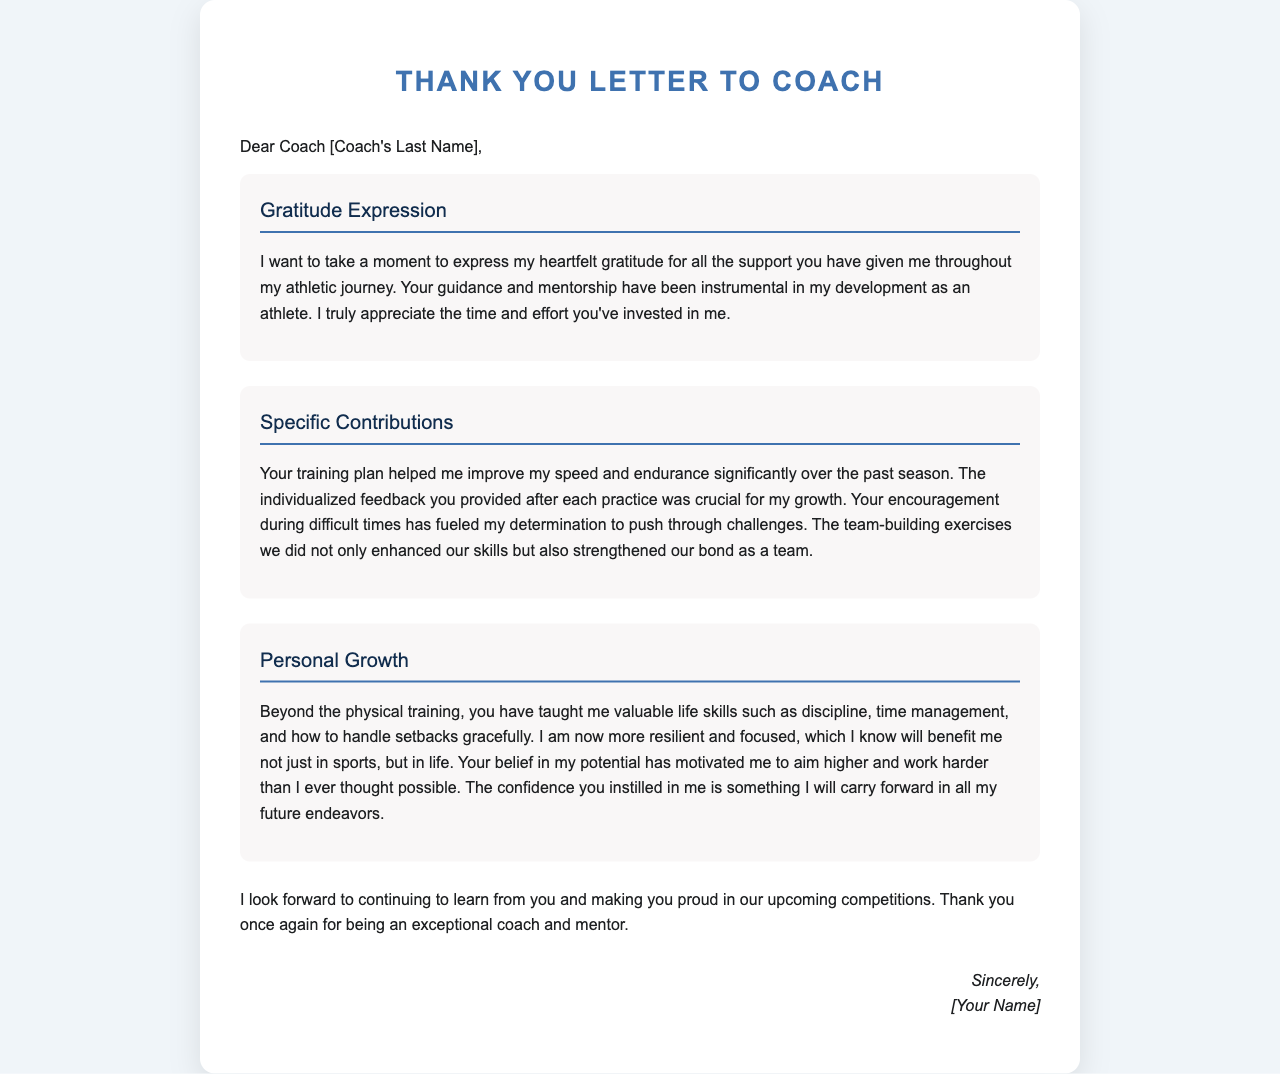What is the title of the letter? The title is clearly stated at the beginning of the document and is indicative of the letter's purpose.
Answer: Thank You Letter to Coach Who is the letter addressed to? The letter includes a placeholder for the recipient's name, specifically indicating the role they play in the author's life.
Answer: Coach [Coach's Last Name] What season did the author mention in their letter? The specific timeframe of the author’s athletic performance improvement is highlighted within the content of the letter.
Answer: Past season What skills did the coach help the author develop besides athletic skills? The letter explicitly mentions valuable life skills that the coach contributed to the author's growth.
Answer: Discipline, time management, handling setbacks What does the author look forward to doing in the future? The author expresses their eagerness regarding future events and ongoing learning from the coach in this closing statement.
Answer: Continuing to learn from you What expression of gratitude does the author make? The author shares a sentiment that reflects their feelings toward the coach's contributions in their athletic journey.
Answer: Heartfelt gratitude What type of letter is this? The specific format and content of the letter suggest its primary purpose within the context.
Answer: Thank-you letter What has the coach instilled in the author aside from skills? The author identifies a profound impact that transcends physical training, emphasizing an emotional growth aspect.
Answer: Confidence 